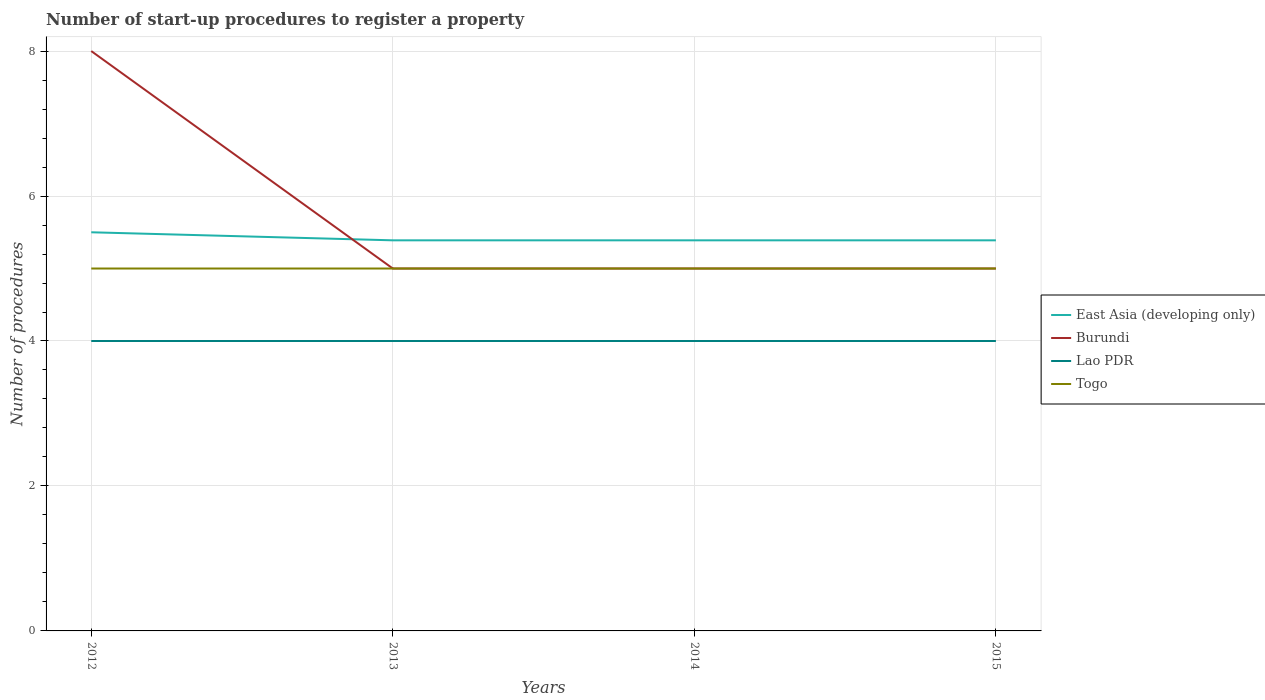How many different coloured lines are there?
Give a very brief answer. 4. Does the line corresponding to Lao PDR intersect with the line corresponding to Togo?
Ensure brevity in your answer.  No. Across all years, what is the maximum number of procedures required to register a property in East Asia (developing only)?
Your answer should be compact. 5.39. In which year was the number of procedures required to register a property in Lao PDR maximum?
Ensure brevity in your answer.  2012. What is the total number of procedures required to register a property in East Asia (developing only) in the graph?
Your answer should be compact. 0. How many lines are there?
Ensure brevity in your answer.  4. Does the graph contain any zero values?
Keep it short and to the point. No. How are the legend labels stacked?
Ensure brevity in your answer.  Vertical. What is the title of the graph?
Your answer should be very brief. Number of start-up procedures to register a property. Does "North America" appear as one of the legend labels in the graph?
Ensure brevity in your answer.  No. What is the label or title of the X-axis?
Keep it short and to the point. Years. What is the label or title of the Y-axis?
Offer a terse response. Number of procedures. What is the Number of procedures in East Asia (developing only) in 2012?
Offer a very short reply. 5.5. What is the Number of procedures of Togo in 2012?
Provide a short and direct response. 5. What is the Number of procedures of East Asia (developing only) in 2013?
Provide a short and direct response. 5.39. What is the Number of procedures of Lao PDR in 2013?
Your response must be concise. 4. What is the Number of procedures in East Asia (developing only) in 2014?
Give a very brief answer. 5.39. What is the Number of procedures in Burundi in 2014?
Offer a terse response. 5. What is the Number of procedures in Lao PDR in 2014?
Your answer should be compact. 4. What is the Number of procedures in East Asia (developing only) in 2015?
Give a very brief answer. 5.39. Across all years, what is the maximum Number of procedures in Burundi?
Offer a terse response. 8. Across all years, what is the minimum Number of procedures of East Asia (developing only)?
Your response must be concise. 5.39. Across all years, what is the minimum Number of procedures of Burundi?
Offer a terse response. 5. Across all years, what is the minimum Number of procedures of Lao PDR?
Your answer should be very brief. 4. What is the total Number of procedures of East Asia (developing only) in the graph?
Your response must be concise. 21.67. What is the difference between the Number of procedures of East Asia (developing only) in 2012 and that in 2013?
Your answer should be compact. 0.11. What is the difference between the Number of procedures of Burundi in 2012 and that in 2013?
Provide a succinct answer. 3. What is the difference between the Number of procedures of Togo in 2012 and that in 2014?
Give a very brief answer. 0. What is the difference between the Number of procedures of Lao PDR in 2012 and that in 2015?
Provide a short and direct response. 0. What is the difference between the Number of procedures in Burundi in 2013 and that in 2014?
Give a very brief answer. 0. What is the difference between the Number of procedures in Togo in 2013 and that in 2014?
Provide a short and direct response. 0. What is the difference between the Number of procedures of Lao PDR in 2013 and that in 2015?
Make the answer very short. 0. What is the difference between the Number of procedures of Togo in 2013 and that in 2015?
Make the answer very short. 0. What is the difference between the Number of procedures in Lao PDR in 2014 and that in 2015?
Make the answer very short. 0. What is the difference between the Number of procedures of Togo in 2014 and that in 2015?
Provide a succinct answer. 0. What is the difference between the Number of procedures of East Asia (developing only) in 2012 and the Number of procedures of Burundi in 2013?
Your response must be concise. 0.5. What is the difference between the Number of procedures in East Asia (developing only) in 2012 and the Number of procedures in Lao PDR in 2013?
Offer a very short reply. 1.5. What is the difference between the Number of procedures in East Asia (developing only) in 2012 and the Number of procedures in Togo in 2013?
Offer a very short reply. 0.5. What is the difference between the Number of procedures of Lao PDR in 2012 and the Number of procedures of Togo in 2013?
Provide a succinct answer. -1. What is the difference between the Number of procedures of East Asia (developing only) in 2012 and the Number of procedures of Burundi in 2014?
Give a very brief answer. 0.5. What is the difference between the Number of procedures of East Asia (developing only) in 2012 and the Number of procedures of Lao PDR in 2014?
Your answer should be compact. 1.5. What is the difference between the Number of procedures in East Asia (developing only) in 2012 and the Number of procedures in Togo in 2014?
Make the answer very short. 0.5. What is the difference between the Number of procedures of Burundi in 2012 and the Number of procedures of Lao PDR in 2014?
Make the answer very short. 4. What is the difference between the Number of procedures in Burundi in 2012 and the Number of procedures in Togo in 2014?
Ensure brevity in your answer.  3. What is the difference between the Number of procedures of East Asia (developing only) in 2012 and the Number of procedures of Burundi in 2015?
Your answer should be very brief. 0.5. What is the difference between the Number of procedures of East Asia (developing only) in 2012 and the Number of procedures of Lao PDR in 2015?
Your response must be concise. 1.5. What is the difference between the Number of procedures in East Asia (developing only) in 2012 and the Number of procedures in Togo in 2015?
Your answer should be compact. 0.5. What is the difference between the Number of procedures of Burundi in 2012 and the Number of procedures of Lao PDR in 2015?
Give a very brief answer. 4. What is the difference between the Number of procedures in Burundi in 2012 and the Number of procedures in Togo in 2015?
Your answer should be very brief. 3. What is the difference between the Number of procedures in Lao PDR in 2012 and the Number of procedures in Togo in 2015?
Provide a succinct answer. -1. What is the difference between the Number of procedures of East Asia (developing only) in 2013 and the Number of procedures of Burundi in 2014?
Your answer should be very brief. 0.39. What is the difference between the Number of procedures in East Asia (developing only) in 2013 and the Number of procedures in Lao PDR in 2014?
Give a very brief answer. 1.39. What is the difference between the Number of procedures in East Asia (developing only) in 2013 and the Number of procedures in Togo in 2014?
Make the answer very short. 0.39. What is the difference between the Number of procedures of Burundi in 2013 and the Number of procedures of Togo in 2014?
Your response must be concise. 0. What is the difference between the Number of procedures of Lao PDR in 2013 and the Number of procedures of Togo in 2014?
Your response must be concise. -1. What is the difference between the Number of procedures in East Asia (developing only) in 2013 and the Number of procedures in Burundi in 2015?
Your answer should be very brief. 0.39. What is the difference between the Number of procedures in East Asia (developing only) in 2013 and the Number of procedures in Lao PDR in 2015?
Ensure brevity in your answer.  1.39. What is the difference between the Number of procedures of East Asia (developing only) in 2013 and the Number of procedures of Togo in 2015?
Provide a succinct answer. 0.39. What is the difference between the Number of procedures in Burundi in 2013 and the Number of procedures in Lao PDR in 2015?
Provide a short and direct response. 1. What is the difference between the Number of procedures of East Asia (developing only) in 2014 and the Number of procedures of Burundi in 2015?
Ensure brevity in your answer.  0.39. What is the difference between the Number of procedures of East Asia (developing only) in 2014 and the Number of procedures of Lao PDR in 2015?
Your answer should be very brief. 1.39. What is the difference between the Number of procedures of East Asia (developing only) in 2014 and the Number of procedures of Togo in 2015?
Make the answer very short. 0.39. What is the difference between the Number of procedures of Burundi in 2014 and the Number of procedures of Lao PDR in 2015?
Your response must be concise. 1. What is the difference between the Number of procedures of Burundi in 2014 and the Number of procedures of Togo in 2015?
Your response must be concise. 0. What is the difference between the Number of procedures in Lao PDR in 2014 and the Number of procedures in Togo in 2015?
Your answer should be very brief. -1. What is the average Number of procedures of East Asia (developing only) per year?
Offer a terse response. 5.42. What is the average Number of procedures in Burundi per year?
Your response must be concise. 5.75. What is the average Number of procedures of Togo per year?
Offer a very short reply. 5. In the year 2012, what is the difference between the Number of procedures of East Asia (developing only) and Number of procedures of Burundi?
Provide a short and direct response. -2.5. In the year 2012, what is the difference between the Number of procedures in East Asia (developing only) and Number of procedures in Lao PDR?
Keep it short and to the point. 1.5. In the year 2012, what is the difference between the Number of procedures in Burundi and Number of procedures in Lao PDR?
Provide a succinct answer. 4. In the year 2012, what is the difference between the Number of procedures of Lao PDR and Number of procedures of Togo?
Provide a short and direct response. -1. In the year 2013, what is the difference between the Number of procedures of East Asia (developing only) and Number of procedures of Burundi?
Your answer should be compact. 0.39. In the year 2013, what is the difference between the Number of procedures in East Asia (developing only) and Number of procedures in Lao PDR?
Keep it short and to the point. 1.39. In the year 2013, what is the difference between the Number of procedures in East Asia (developing only) and Number of procedures in Togo?
Give a very brief answer. 0.39. In the year 2013, what is the difference between the Number of procedures in Burundi and Number of procedures in Togo?
Keep it short and to the point. 0. In the year 2014, what is the difference between the Number of procedures in East Asia (developing only) and Number of procedures in Burundi?
Your answer should be very brief. 0.39. In the year 2014, what is the difference between the Number of procedures in East Asia (developing only) and Number of procedures in Lao PDR?
Your answer should be very brief. 1.39. In the year 2014, what is the difference between the Number of procedures of East Asia (developing only) and Number of procedures of Togo?
Provide a succinct answer. 0.39. In the year 2014, what is the difference between the Number of procedures in Burundi and Number of procedures in Lao PDR?
Your answer should be compact. 1. In the year 2014, what is the difference between the Number of procedures of Burundi and Number of procedures of Togo?
Make the answer very short. 0. In the year 2014, what is the difference between the Number of procedures of Lao PDR and Number of procedures of Togo?
Provide a short and direct response. -1. In the year 2015, what is the difference between the Number of procedures in East Asia (developing only) and Number of procedures in Burundi?
Provide a short and direct response. 0.39. In the year 2015, what is the difference between the Number of procedures in East Asia (developing only) and Number of procedures in Lao PDR?
Your response must be concise. 1.39. In the year 2015, what is the difference between the Number of procedures of East Asia (developing only) and Number of procedures of Togo?
Offer a very short reply. 0.39. In the year 2015, what is the difference between the Number of procedures in Burundi and Number of procedures in Lao PDR?
Ensure brevity in your answer.  1. In the year 2015, what is the difference between the Number of procedures in Lao PDR and Number of procedures in Togo?
Give a very brief answer. -1. What is the ratio of the Number of procedures of East Asia (developing only) in 2012 to that in 2013?
Your response must be concise. 1.02. What is the ratio of the Number of procedures of East Asia (developing only) in 2012 to that in 2014?
Provide a short and direct response. 1.02. What is the ratio of the Number of procedures in Burundi in 2012 to that in 2014?
Keep it short and to the point. 1.6. What is the ratio of the Number of procedures of Lao PDR in 2012 to that in 2014?
Offer a very short reply. 1. What is the ratio of the Number of procedures of East Asia (developing only) in 2012 to that in 2015?
Offer a terse response. 1.02. What is the ratio of the Number of procedures in Lao PDR in 2012 to that in 2015?
Your answer should be very brief. 1. What is the ratio of the Number of procedures of Togo in 2012 to that in 2015?
Provide a short and direct response. 1. What is the ratio of the Number of procedures in Togo in 2013 to that in 2014?
Your answer should be compact. 1. What is the ratio of the Number of procedures in East Asia (developing only) in 2013 to that in 2015?
Your answer should be compact. 1. What is the ratio of the Number of procedures in Burundi in 2013 to that in 2015?
Keep it short and to the point. 1. What is the ratio of the Number of procedures in Lao PDR in 2013 to that in 2015?
Provide a succinct answer. 1. What is the ratio of the Number of procedures of Burundi in 2014 to that in 2015?
Your answer should be very brief. 1. What is the ratio of the Number of procedures of Lao PDR in 2014 to that in 2015?
Make the answer very short. 1. What is the difference between the highest and the second highest Number of procedures of East Asia (developing only)?
Your answer should be very brief. 0.11. What is the difference between the highest and the lowest Number of procedures of East Asia (developing only)?
Give a very brief answer. 0.11. What is the difference between the highest and the lowest Number of procedures of Burundi?
Offer a terse response. 3. What is the difference between the highest and the lowest Number of procedures in Lao PDR?
Give a very brief answer. 0. 